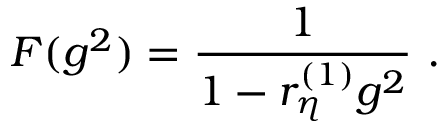<formula> <loc_0><loc_0><loc_500><loc_500>F ( g ^ { 2 } ) = \frac { 1 } 1 - r _ { \eta } ^ { ( 1 ) } g ^ { 2 } } \ .</formula> 